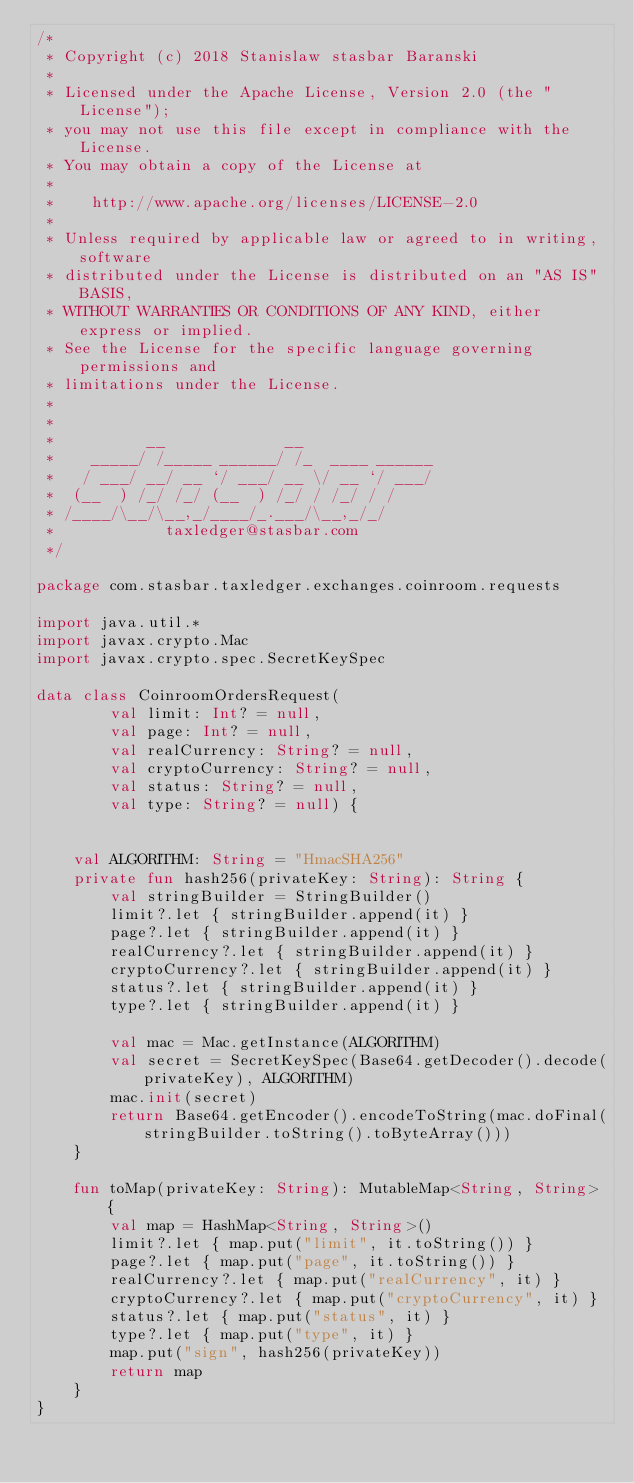<code> <loc_0><loc_0><loc_500><loc_500><_Kotlin_>/*
 * Copyright (c) 2018 Stanislaw stasbar Baranski
 *
 * Licensed under the Apache License, Version 2.0 (the "License");
 * you may not use this file except in compliance with the License.
 * You may obtain a copy of the License at
 *
 *    http://www.apache.org/licenses/LICENSE-2.0
 *
 * Unless required by applicable law or agreed to in writing, software
 * distributed under the License is distributed on an "AS IS" BASIS,
 * WITHOUT WARRANTIES OR CONDITIONS OF ANY KIND, either express or implied.
 * See the License for the specific language governing permissions and
 * limitations under the License.
 *
 *
 *          __             __
 *    _____/ /_____ ______/ /_  ____ ______
 *   / ___/ __/ __ `/ ___/ __ \/ __ `/ ___/
 *  (__  ) /_/ /_/ (__  ) /_/ / /_/ / /
 * /____/\__/\__,_/____/_.___/\__,_/_/
 *            taxledger@stasbar.com
 */

package com.stasbar.taxledger.exchanges.coinroom.requests

import java.util.*
import javax.crypto.Mac
import javax.crypto.spec.SecretKeySpec

data class CoinroomOrdersRequest(
        val limit: Int? = null,
        val page: Int? = null,
        val realCurrency: String? = null,
        val cryptoCurrency: String? = null,
        val status: String? = null,
        val type: String? = null) {


    val ALGORITHM: String = "HmacSHA256"
    private fun hash256(privateKey: String): String {
        val stringBuilder = StringBuilder()
        limit?.let { stringBuilder.append(it) }
        page?.let { stringBuilder.append(it) }
        realCurrency?.let { stringBuilder.append(it) }
        cryptoCurrency?.let { stringBuilder.append(it) }
        status?.let { stringBuilder.append(it) }
        type?.let { stringBuilder.append(it) }

        val mac = Mac.getInstance(ALGORITHM)
        val secret = SecretKeySpec(Base64.getDecoder().decode(privateKey), ALGORITHM)
        mac.init(secret)
        return Base64.getEncoder().encodeToString(mac.doFinal(stringBuilder.toString().toByteArray()))
    }

    fun toMap(privateKey: String): MutableMap<String, String> {
        val map = HashMap<String, String>()
        limit?.let { map.put("limit", it.toString()) }
        page?.let { map.put("page", it.toString()) }
        realCurrency?.let { map.put("realCurrency", it) }
        cryptoCurrency?.let { map.put("cryptoCurrency", it) }
        status?.let { map.put("status", it) }
        type?.let { map.put("type", it) }
        map.put("sign", hash256(privateKey))
        return map
    }
}

</code> 